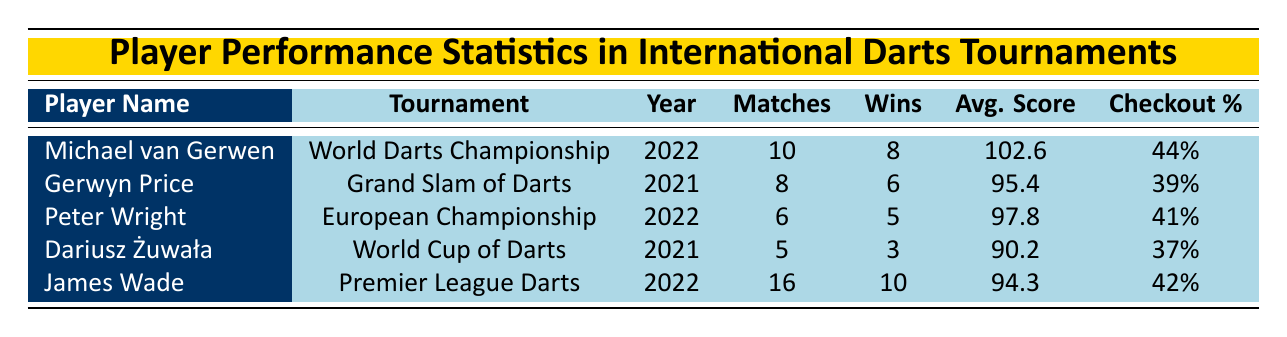What is the average score of Michael van Gerwen? The table shows that Michael van Gerwen had an average score of 102.6 in the World Darts Championship in 2022.
Answer: 102.6 How many matches did James Wade play in the Premier League Darts? The table indicates that James Wade played 16 matches in the Premier League Darts in 2022.
Answer: 16 Did Peter Wright have a higher checkout percentage than Dariusz Żuwała? Peter Wright's checkout percentage is 41%, while Dariusz Żuwała's is 37%. Since 41% is greater than 37%, the answer is yes.
Answer: Yes What is the total number of wins by all players listed in the table? The total wins can be calculated by adding the wins from each player: 8 (van Gerwen) + 6 (Price) + 5 (Wright) + 3 (Żuwała) + 10 (Wade) = 32 wins.
Answer: 32 Which player had the best average score in the table? The table indicates Michael van Gerwen had the highest average score of 102.6, compared to the others: 95.4 (Price), 97.8 (Wright), 90.2 (Żuwała), and 94.3 (Wade). Therefore, Michael van Gerwen has the best average score.
Answer: Michael van Gerwen How many total losses did all players have in the tournaments presented? To find the total losses, sum the losses from each player: 2 (van Gerwen) + 2 (Price) + 1 (Wright) + 2 (Żuwała) + 6 (Wade) = 13 total losses.
Answer: 13 Is Dariusz Żuwała's average score less than 91? Dariusz Żuwała has an average score of 90.2, which is indeed less than 91. Therefore, the answer is yes.
Answer: Yes What percentage of T20s did James Wade hit in his matches? James Wade had a T20 percentage of 25%, which is directly stated in the table under his performance.
Answer: 25% Which tournament did Gerwyn Price play in 2021? According to the table, Gerwyn Price participated in the Grand Slam of Darts in 2021.
Answer: Grand Slam of Darts 